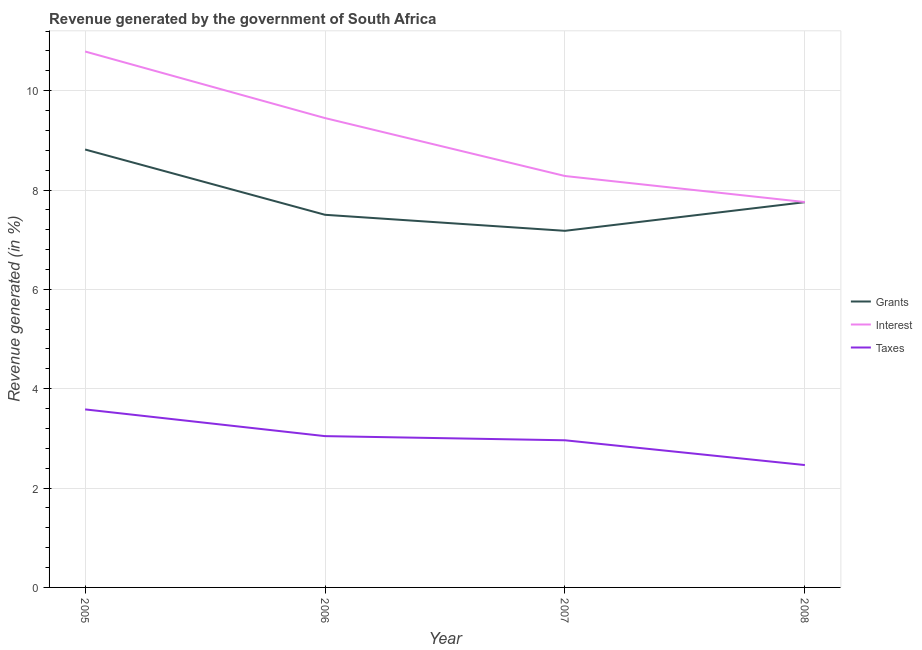Does the line corresponding to percentage of revenue generated by interest intersect with the line corresponding to percentage of revenue generated by grants?
Your response must be concise. No. What is the percentage of revenue generated by interest in 2005?
Your answer should be very brief. 10.79. Across all years, what is the maximum percentage of revenue generated by grants?
Give a very brief answer. 8.82. Across all years, what is the minimum percentage of revenue generated by interest?
Keep it short and to the point. 7.76. What is the total percentage of revenue generated by taxes in the graph?
Offer a very short reply. 12.06. What is the difference between the percentage of revenue generated by taxes in 2006 and that in 2007?
Offer a very short reply. 0.08. What is the difference between the percentage of revenue generated by interest in 2006 and the percentage of revenue generated by taxes in 2005?
Make the answer very short. 5.86. What is the average percentage of revenue generated by grants per year?
Ensure brevity in your answer.  7.81. In the year 2008, what is the difference between the percentage of revenue generated by interest and percentage of revenue generated by taxes?
Your answer should be compact. 5.29. In how many years, is the percentage of revenue generated by grants greater than 2.4 %?
Give a very brief answer. 4. What is the ratio of the percentage of revenue generated by grants in 2005 to that in 2008?
Provide a short and direct response. 1.14. Is the percentage of revenue generated by grants in 2006 less than that in 2007?
Keep it short and to the point. No. What is the difference between the highest and the second highest percentage of revenue generated by taxes?
Your response must be concise. 0.54. What is the difference between the highest and the lowest percentage of revenue generated by taxes?
Your answer should be very brief. 1.12. Is the percentage of revenue generated by taxes strictly less than the percentage of revenue generated by grants over the years?
Make the answer very short. Yes. How many lines are there?
Offer a very short reply. 3. How many legend labels are there?
Your answer should be compact. 3. How are the legend labels stacked?
Your response must be concise. Vertical. What is the title of the graph?
Your answer should be compact. Revenue generated by the government of South Africa. Does "Ages 0-14" appear as one of the legend labels in the graph?
Offer a terse response. No. What is the label or title of the Y-axis?
Offer a very short reply. Revenue generated (in %). What is the Revenue generated (in %) of Grants in 2005?
Offer a terse response. 8.82. What is the Revenue generated (in %) in Interest in 2005?
Keep it short and to the point. 10.79. What is the Revenue generated (in %) in Taxes in 2005?
Give a very brief answer. 3.58. What is the Revenue generated (in %) in Grants in 2006?
Your answer should be very brief. 7.5. What is the Revenue generated (in %) of Interest in 2006?
Offer a very short reply. 9.45. What is the Revenue generated (in %) of Taxes in 2006?
Make the answer very short. 3.05. What is the Revenue generated (in %) of Grants in 2007?
Offer a terse response. 7.18. What is the Revenue generated (in %) of Interest in 2007?
Give a very brief answer. 8.28. What is the Revenue generated (in %) of Taxes in 2007?
Offer a terse response. 2.96. What is the Revenue generated (in %) of Grants in 2008?
Offer a terse response. 7.76. What is the Revenue generated (in %) in Interest in 2008?
Your answer should be compact. 7.76. What is the Revenue generated (in %) in Taxes in 2008?
Your answer should be compact. 2.46. Across all years, what is the maximum Revenue generated (in %) in Grants?
Your answer should be compact. 8.82. Across all years, what is the maximum Revenue generated (in %) in Interest?
Provide a succinct answer. 10.79. Across all years, what is the maximum Revenue generated (in %) in Taxes?
Your answer should be compact. 3.58. Across all years, what is the minimum Revenue generated (in %) in Grants?
Provide a short and direct response. 7.18. Across all years, what is the minimum Revenue generated (in %) in Interest?
Keep it short and to the point. 7.76. Across all years, what is the minimum Revenue generated (in %) in Taxes?
Make the answer very short. 2.46. What is the total Revenue generated (in %) of Grants in the graph?
Ensure brevity in your answer.  31.25. What is the total Revenue generated (in %) of Interest in the graph?
Your response must be concise. 36.28. What is the total Revenue generated (in %) of Taxes in the graph?
Make the answer very short. 12.06. What is the difference between the Revenue generated (in %) in Grants in 2005 and that in 2006?
Provide a succinct answer. 1.31. What is the difference between the Revenue generated (in %) in Interest in 2005 and that in 2006?
Ensure brevity in your answer.  1.34. What is the difference between the Revenue generated (in %) in Taxes in 2005 and that in 2006?
Provide a short and direct response. 0.54. What is the difference between the Revenue generated (in %) of Grants in 2005 and that in 2007?
Provide a short and direct response. 1.64. What is the difference between the Revenue generated (in %) of Interest in 2005 and that in 2007?
Your answer should be very brief. 2.51. What is the difference between the Revenue generated (in %) of Taxes in 2005 and that in 2007?
Your answer should be very brief. 0.62. What is the difference between the Revenue generated (in %) of Grants in 2005 and that in 2008?
Offer a very short reply. 1.06. What is the difference between the Revenue generated (in %) in Interest in 2005 and that in 2008?
Provide a succinct answer. 3.03. What is the difference between the Revenue generated (in %) in Taxes in 2005 and that in 2008?
Your response must be concise. 1.12. What is the difference between the Revenue generated (in %) in Grants in 2006 and that in 2007?
Keep it short and to the point. 0.32. What is the difference between the Revenue generated (in %) in Interest in 2006 and that in 2007?
Provide a short and direct response. 1.17. What is the difference between the Revenue generated (in %) of Taxes in 2006 and that in 2007?
Your answer should be compact. 0.08. What is the difference between the Revenue generated (in %) in Grants in 2006 and that in 2008?
Your response must be concise. -0.25. What is the difference between the Revenue generated (in %) in Interest in 2006 and that in 2008?
Offer a very short reply. 1.69. What is the difference between the Revenue generated (in %) of Taxes in 2006 and that in 2008?
Provide a short and direct response. 0.58. What is the difference between the Revenue generated (in %) of Grants in 2007 and that in 2008?
Keep it short and to the point. -0.58. What is the difference between the Revenue generated (in %) of Interest in 2007 and that in 2008?
Provide a succinct answer. 0.52. What is the difference between the Revenue generated (in %) in Taxes in 2007 and that in 2008?
Provide a succinct answer. 0.5. What is the difference between the Revenue generated (in %) in Grants in 2005 and the Revenue generated (in %) in Interest in 2006?
Ensure brevity in your answer.  -0.63. What is the difference between the Revenue generated (in %) in Grants in 2005 and the Revenue generated (in %) in Taxes in 2006?
Make the answer very short. 5.77. What is the difference between the Revenue generated (in %) in Interest in 2005 and the Revenue generated (in %) in Taxes in 2006?
Your response must be concise. 7.74. What is the difference between the Revenue generated (in %) of Grants in 2005 and the Revenue generated (in %) of Interest in 2007?
Offer a terse response. 0.53. What is the difference between the Revenue generated (in %) in Grants in 2005 and the Revenue generated (in %) in Taxes in 2007?
Ensure brevity in your answer.  5.85. What is the difference between the Revenue generated (in %) in Interest in 2005 and the Revenue generated (in %) in Taxes in 2007?
Your answer should be compact. 7.83. What is the difference between the Revenue generated (in %) in Grants in 2005 and the Revenue generated (in %) in Interest in 2008?
Keep it short and to the point. 1.06. What is the difference between the Revenue generated (in %) of Grants in 2005 and the Revenue generated (in %) of Taxes in 2008?
Your answer should be compact. 6.35. What is the difference between the Revenue generated (in %) of Interest in 2005 and the Revenue generated (in %) of Taxes in 2008?
Your response must be concise. 8.33. What is the difference between the Revenue generated (in %) of Grants in 2006 and the Revenue generated (in %) of Interest in 2007?
Ensure brevity in your answer.  -0.78. What is the difference between the Revenue generated (in %) in Grants in 2006 and the Revenue generated (in %) in Taxes in 2007?
Offer a very short reply. 4.54. What is the difference between the Revenue generated (in %) in Interest in 2006 and the Revenue generated (in %) in Taxes in 2007?
Your response must be concise. 6.49. What is the difference between the Revenue generated (in %) in Grants in 2006 and the Revenue generated (in %) in Interest in 2008?
Make the answer very short. -0.26. What is the difference between the Revenue generated (in %) of Grants in 2006 and the Revenue generated (in %) of Taxes in 2008?
Your response must be concise. 5.04. What is the difference between the Revenue generated (in %) in Interest in 2006 and the Revenue generated (in %) in Taxes in 2008?
Make the answer very short. 6.99. What is the difference between the Revenue generated (in %) in Grants in 2007 and the Revenue generated (in %) in Interest in 2008?
Offer a terse response. -0.58. What is the difference between the Revenue generated (in %) of Grants in 2007 and the Revenue generated (in %) of Taxes in 2008?
Make the answer very short. 4.72. What is the difference between the Revenue generated (in %) in Interest in 2007 and the Revenue generated (in %) in Taxes in 2008?
Offer a terse response. 5.82. What is the average Revenue generated (in %) in Grants per year?
Offer a very short reply. 7.81. What is the average Revenue generated (in %) in Interest per year?
Your answer should be very brief. 9.07. What is the average Revenue generated (in %) in Taxes per year?
Ensure brevity in your answer.  3.01. In the year 2005, what is the difference between the Revenue generated (in %) in Grants and Revenue generated (in %) in Interest?
Offer a very short reply. -1.97. In the year 2005, what is the difference between the Revenue generated (in %) of Grants and Revenue generated (in %) of Taxes?
Offer a very short reply. 5.23. In the year 2005, what is the difference between the Revenue generated (in %) in Interest and Revenue generated (in %) in Taxes?
Make the answer very short. 7.21. In the year 2006, what is the difference between the Revenue generated (in %) in Grants and Revenue generated (in %) in Interest?
Make the answer very short. -1.95. In the year 2006, what is the difference between the Revenue generated (in %) in Grants and Revenue generated (in %) in Taxes?
Give a very brief answer. 4.46. In the year 2006, what is the difference between the Revenue generated (in %) of Interest and Revenue generated (in %) of Taxes?
Offer a terse response. 6.4. In the year 2007, what is the difference between the Revenue generated (in %) in Grants and Revenue generated (in %) in Interest?
Give a very brief answer. -1.1. In the year 2007, what is the difference between the Revenue generated (in %) in Grants and Revenue generated (in %) in Taxes?
Ensure brevity in your answer.  4.22. In the year 2007, what is the difference between the Revenue generated (in %) in Interest and Revenue generated (in %) in Taxes?
Provide a succinct answer. 5.32. In the year 2008, what is the difference between the Revenue generated (in %) of Grants and Revenue generated (in %) of Interest?
Ensure brevity in your answer.  -0. In the year 2008, what is the difference between the Revenue generated (in %) in Grants and Revenue generated (in %) in Taxes?
Provide a short and direct response. 5.29. In the year 2008, what is the difference between the Revenue generated (in %) of Interest and Revenue generated (in %) of Taxes?
Provide a short and direct response. 5.29. What is the ratio of the Revenue generated (in %) of Grants in 2005 to that in 2006?
Keep it short and to the point. 1.18. What is the ratio of the Revenue generated (in %) of Interest in 2005 to that in 2006?
Offer a terse response. 1.14. What is the ratio of the Revenue generated (in %) of Taxes in 2005 to that in 2006?
Make the answer very short. 1.18. What is the ratio of the Revenue generated (in %) in Grants in 2005 to that in 2007?
Your response must be concise. 1.23. What is the ratio of the Revenue generated (in %) of Interest in 2005 to that in 2007?
Your response must be concise. 1.3. What is the ratio of the Revenue generated (in %) in Taxes in 2005 to that in 2007?
Keep it short and to the point. 1.21. What is the ratio of the Revenue generated (in %) in Grants in 2005 to that in 2008?
Your answer should be compact. 1.14. What is the ratio of the Revenue generated (in %) of Interest in 2005 to that in 2008?
Make the answer very short. 1.39. What is the ratio of the Revenue generated (in %) in Taxes in 2005 to that in 2008?
Keep it short and to the point. 1.45. What is the ratio of the Revenue generated (in %) in Grants in 2006 to that in 2007?
Make the answer very short. 1.04. What is the ratio of the Revenue generated (in %) in Interest in 2006 to that in 2007?
Your answer should be very brief. 1.14. What is the ratio of the Revenue generated (in %) in Taxes in 2006 to that in 2007?
Your answer should be compact. 1.03. What is the ratio of the Revenue generated (in %) in Grants in 2006 to that in 2008?
Make the answer very short. 0.97. What is the ratio of the Revenue generated (in %) in Interest in 2006 to that in 2008?
Give a very brief answer. 1.22. What is the ratio of the Revenue generated (in %) of Taxes in 2006 to that in 2008?
Your answer should be compact. 1.24. What is the ratio of the Revenue generated (in %) in Grants in 2007 to that in 2008?
Give a very brief answer. 0.93. What is the ratio of the Revenue generated (in %) of Interest in 2007 to that in 2008?
Make the answer very short. 1.07. What is the ratio of the Revenue generated (in %) of Taxes in 2007 to that in 2008?
Keep it short and to the point. 1.2. What is the difference between the highest and the second highest Revenue generated (in %) in Grants?
Provide a succinct answer. 1.06. What is the difference between the highest and the second highest Revenue generated (in %) of Interest?
Offer a very short reply. 1.34. What is the difference between the highest and the second highest Revenue generated (in %) in Taxes?
Offer a very short reply. 0.54. What is the difference between the highest and the lowest Revenue generated (in %) of Grants?
Ensure brevity in your answer.  1.64. What is the difference between the highest and the lowest Revenue generated (in %) in Interest?
Provide a short and direct response. 3.03. What is the difference between the highest and the lowest Revenue generated (in %) in Taxes?
Your answer should be very brief. 1.12. 